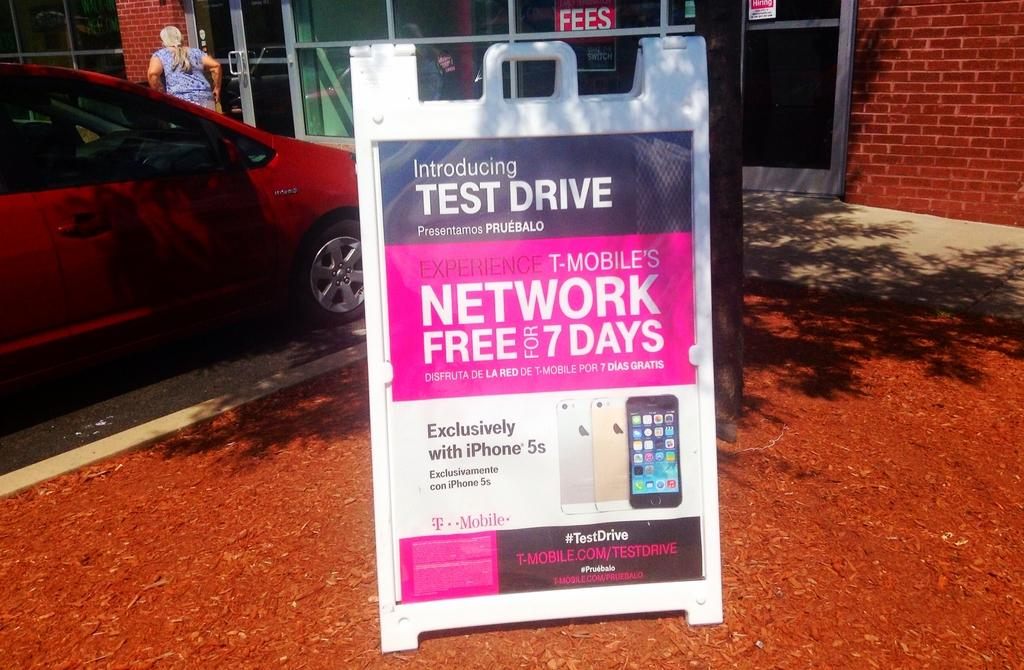What is located at the bottom of the image? There is an advertising board at the bottom of the image. What can be seen on the left side of the image? There is a car and a woman on the left side of the image. What is visible in the background of the image? There is a building in the background of the image. What type of crib is featured in the image? There is no crib present in the image. What selection of appliances can be seen in the image? There is no mention of appliances in the image; it features an advertising board, a car, a woman, and a building. 